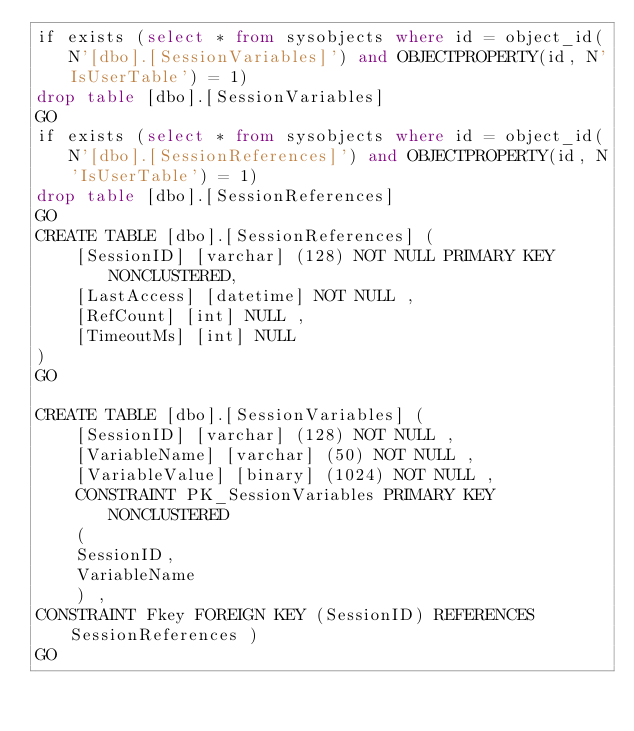<code> <loc_0><loc_0><loc_500><loc_500><_SQL_>if exists (select * from sysobjects where id = object_id(N'[dbo].[SessionVariables]') and OBJECTPROPERTY(id, N'IsUserTable') = 1)
drop table [dbo].[SessionVariables]
GO
if exists (select * from sysobjects where id = object_id(N'[dbo].[SessionReferences]') and OBJECTPROPERTY(id, N'IsUserTable') = 1)
drop table [dbo].[SessionReferences]
GO
CREATE TABLE [dbo].[SessionReferences] (
	[SessionID] [varchar] (128) NOT NULL PRIMARY KEY NONCLUSTERED,
	[LastAccess] [datetime] NOT NULL ,
	[RefCount] [int] NULL ,
	[TimeoutMs] [int] NULL
)
GO

CREATE TABLE [dbo].[SessionVariables] (
	[SessionID] [varchar] (128) NOT NULL ,
	[VariableName] [varchar] (50) NOT NULL ,
	[VariableValue] [binary] (1024) NOT NULL ,
	CONSTRAINT PK_SessionVariables PRIMARY KEY NONCLUSTERED 
	(
	SessionID,
	VariableName
	) , 
CONSTRAINT Fkey FOREIGN KEY (SessionID) REFERENCES SessionReferences )
GO</code> 